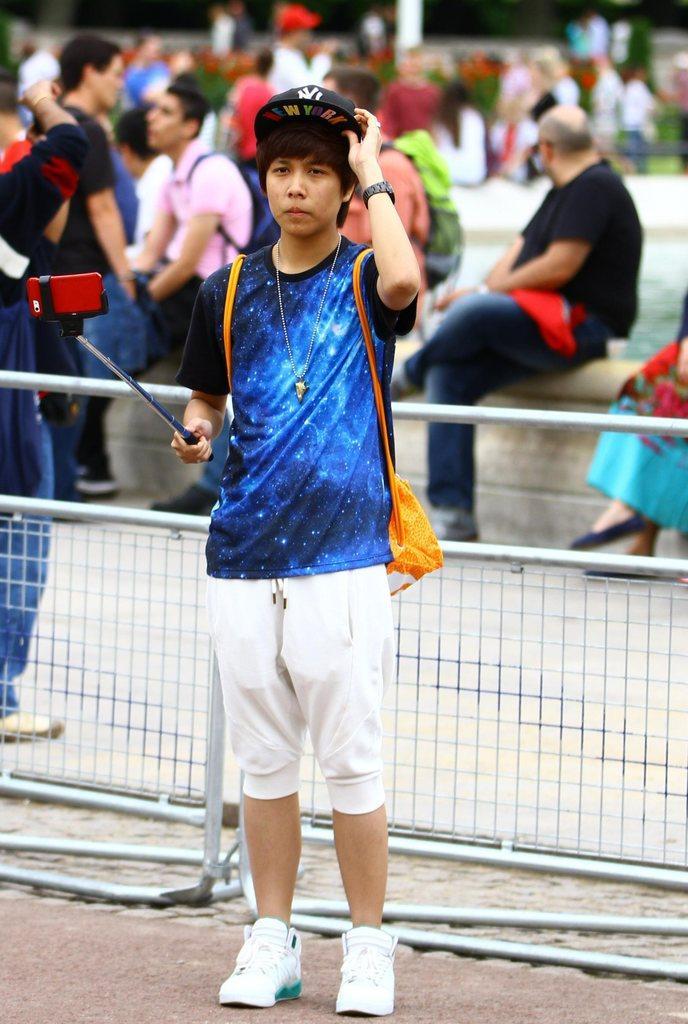Please provide a concise description of this image. In this image, in the middle there is a man, he wears a t shirt, trouser, shoes, cap, he is holding a stick. In the background, there are people sitting, some are standing, fence. 